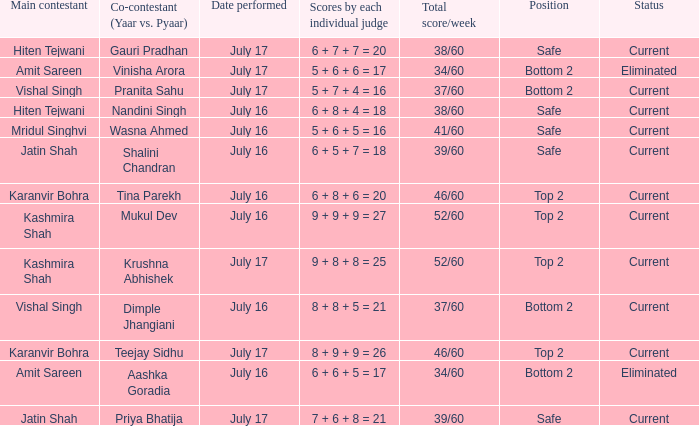Who performed with Tina Parekh? Karanvir Bohra. Could you parse the entire table as a dict? {'header': ['Main contestant', 'Co-contestant (Yaar vs. Pyaar)', 'Date performed', 'Scores by each individual judge', 'Total score/week', 'Position', 'Status'], 'rows': [['Hiten Tejwani', 'Gauri Pradhan', 'July 17', '6 + 7 + 7 = 20', '38/60', 'Safe', 'Current'], ['Amit Sareen', 'Vinisha Arora', 'July 17', '5 + 6 + 6 = 17', '34/60', 'Bottom 2', 'Eliminated'], ['Vishal Singh', 'Pranita Sahu', 'July 17', '5 + 7 + 4 = 16', '37/60', 'Bottom 2', 'Current'], ['Hiten Tejwani', 'Nandini Singh', 'July 16', '6 + 8 + 4 = 18', '38/60', 'Safe', 'Current'], ['Mridul Singhvi', 'Wasna Ahmed', 'July 16', '5 + 6 + 5 = 16', '41/60', 'Safe', 'Current'], ['Jatin Shah', 'Shalini Chandran', 'July 16', '6 + 5 + 7 = 18', '39/60', 'Safe', 'Current'], ['Karanvir Bohra', 'Tina Parekh', 'July 16', '6 + 8 + 6 = 20', '46/60', 'Top 2', 'Current'], ['Kashmira Shah', 'Mukul Dev', 'July 16', '9 + 9 + 9 = 27', '52/60', 'Top 2', 'Current'], ['Kashmira Shah', 'Krushna Abhishek', 'July 17', '9 + 8 + 8 = 25', '52/60', 'Top 2', 'Current'], ['Vishal Singh', 'Dimple Jhangiani', 'July 16', '8 + 8 + 5 = 21', '37/60', 'Bottom 2', 'Current'], ['Karanvir Bohra', 'Teejay Sidhu', 'July 17', '8 + 9 + 9 = 26', '46/60', 'Top 2', 'Current'], ['Amit Sareen', 'Aashka Goradia', 'July 16', '6 + 6 + 5 = 17', '34/60', 'Bottom 2', 'Eliminated'], ['Jatin Shah', 'Priya Bhatija', 'July 17', '7 + 6 + 8 = 21', '39/60', 'Safe', 'Current']]} 